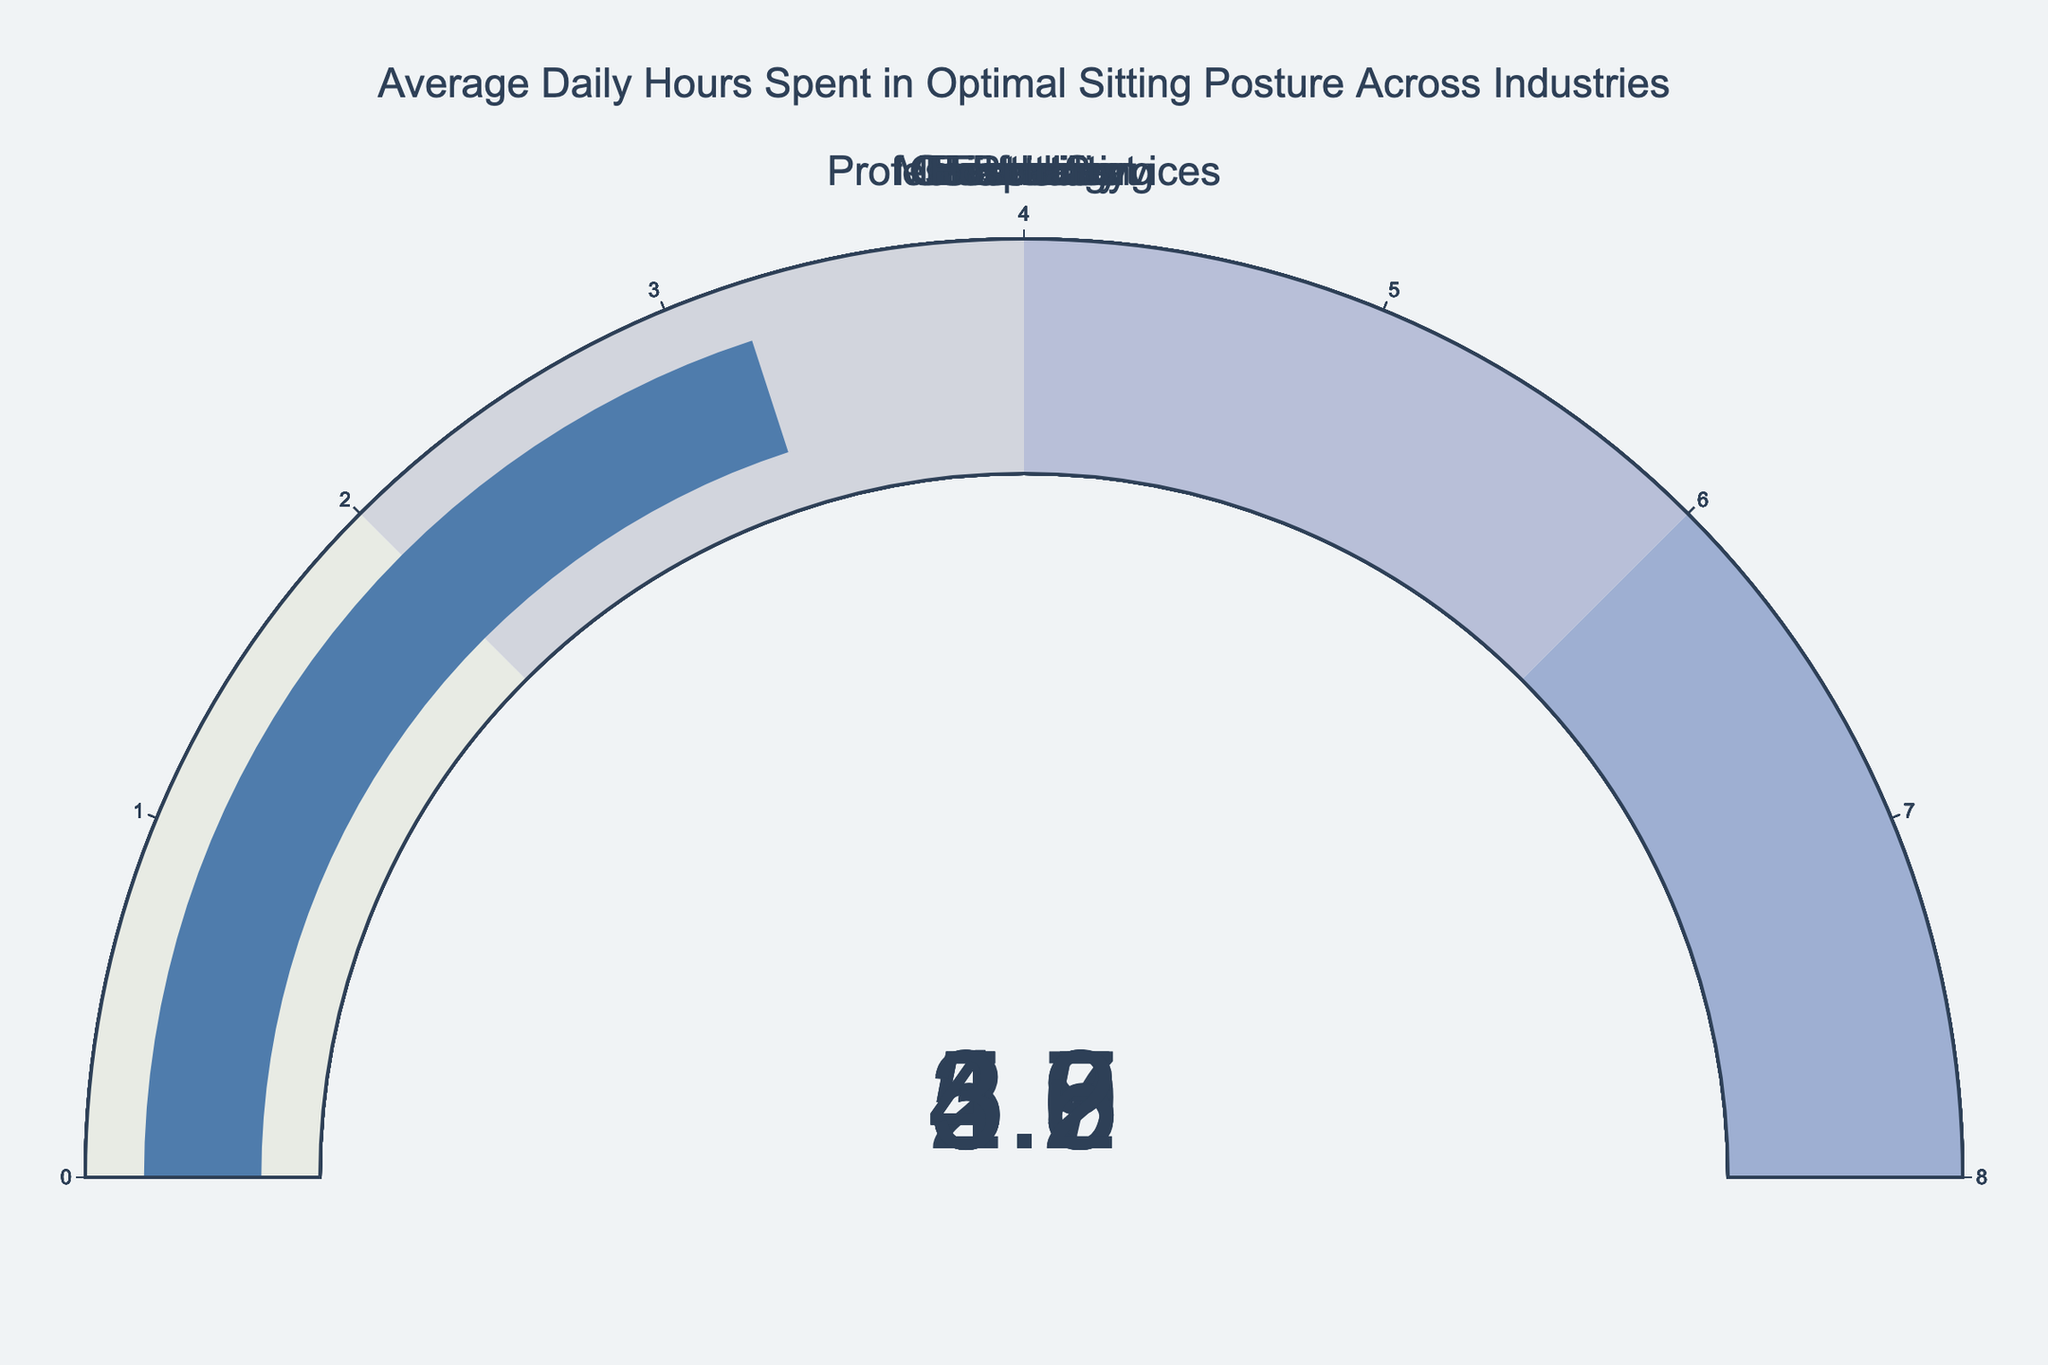What's the average daily hours spent in an optimal sitting posture for the Technology industry? The gauge chart for the Technology industry shows an indicator pointing to the value of hours spent in an optimal sitting posture. The number displayed is 5.2
Answer: 5.2 Which industry has the lowest average daily hours spent in an optimal sitting posture? By comparing the values on all the gauges, we see that the Construction industry has the lowest value with 2.9 hours.
Answer: Construction What is the difference in average daily hours spent in an optimal sitting posture between the Finance and Retail industries? The Finance industry has an average of 5.5 hours, while the Retail industry shows 3.5 hours. Subtracting these values gives the difference: 5.5 - 3.5 = 2.0 hours.
Answer: 2.0 How many industries have an average daily hours spent in an optimal sitting posture of 5 hours or more? By examining the values on the gauges, the Technology (5.2), Finance (5.5), Professional Services (5.3), and Education (4.9 is less than 5 but close). Thus, 3 industries have 5 or more hours.
Answer: 3 What is the average daily hours spent in an optimal sitting posture across all listed industries? Sum all the given values: 5.2 + 4.7 + 5.5 + 3.8 + 4.9 + 3.5 + 2.9 + 5.3 + 4.6 + 3.2 = 43.6 hours. There are 10 industries, hence the average is 43.6 / 10 = 4.36 hours.
Answer: 4.36 Which two industries have the closest average daily hours spent in an optimal sitting posture, and what are their values? By comparing all the values, Education (4.9 hours) and Healthcare (4.7 hours) are the closest with a difference of 0.2 hours.
Answer: Education (4.9) and Healthcare (4.7) What is the range of average daily hours spent in optimal sitting posture across all industries? The range is found by subtracting the minimum value from the maximum value. The Construction industry has the minimum of 2.9 hours, and Finance has the maximum of 5.5 hours. Thus, the range is 5.5 - 2.9 = 2.6 hours.
Answer: 2.6 Which sector has a slightly lower average than Professional Services but higher than Government? Professional Services has 5.3 hours. The Government has 4.6 hours. The Education industry falls between these values at 4.9 hours.
Answer: Education 